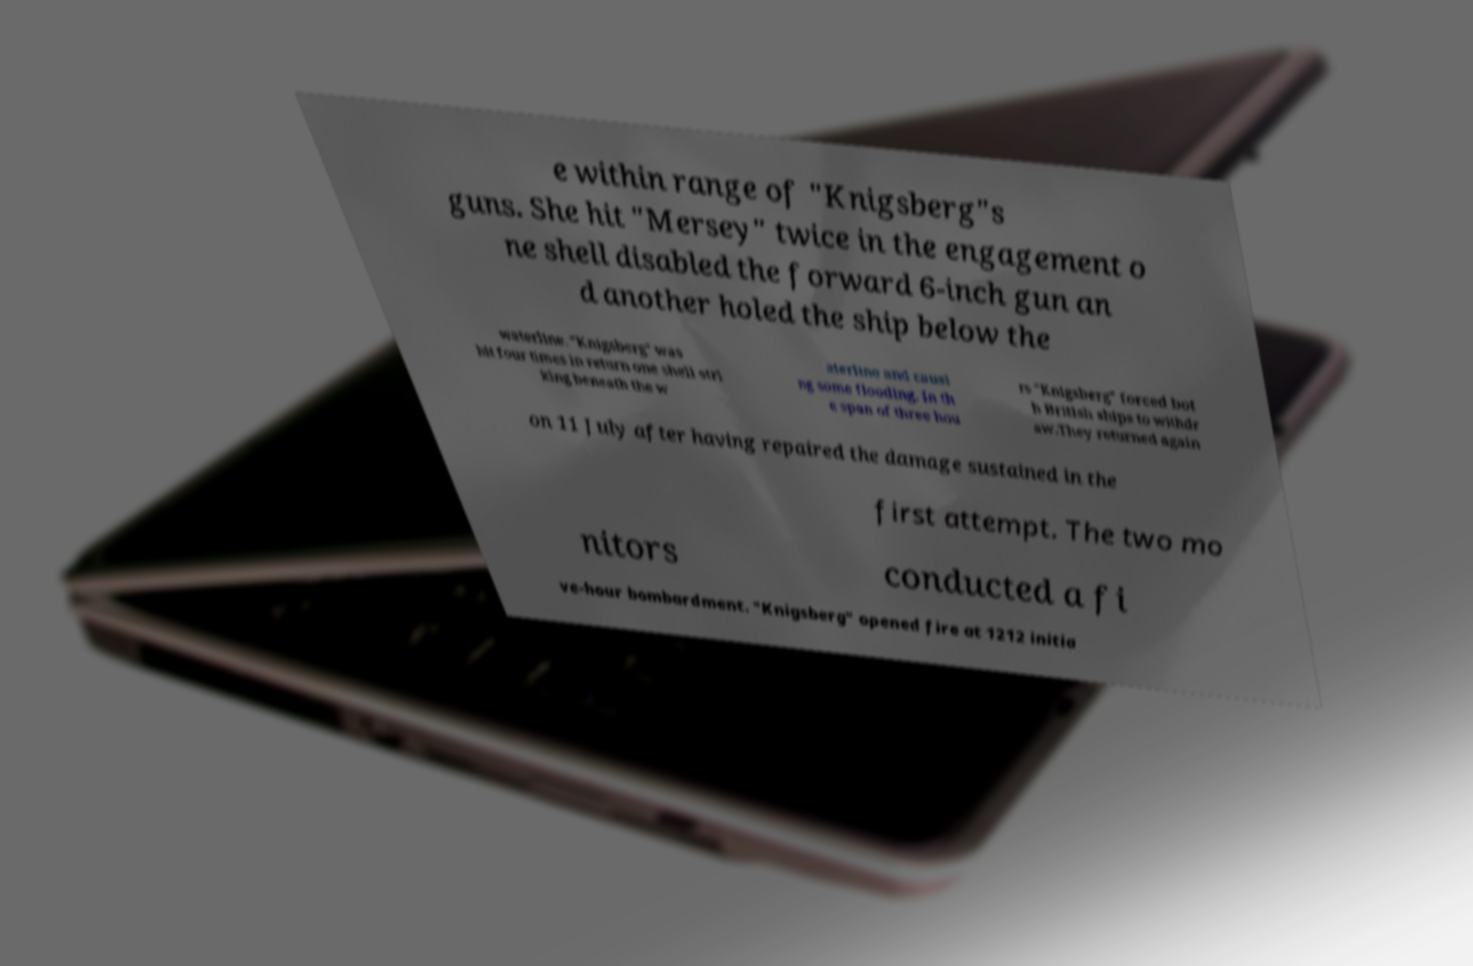Please identify and transcribe the text found in this image. e within range of "Knigsberg"s guns. She hit "Mersey" twice in the engagement o ne shell disabled the forward 6-inch gun an d another holed the ship below the waterline. "Knigsberg" was hit four times in return one shell stri king beneath the w aterline and causi ng some flooding. In th e span of three hou rs "Knigsberg" forced bot h British ships to withdr aw.They returned again on 11 July after having repaired the damage sustained in the first attempt. The two mo nitors conducted a fi ve-hour bombardment. "Knigsberg" opened fire at 1212 initia 